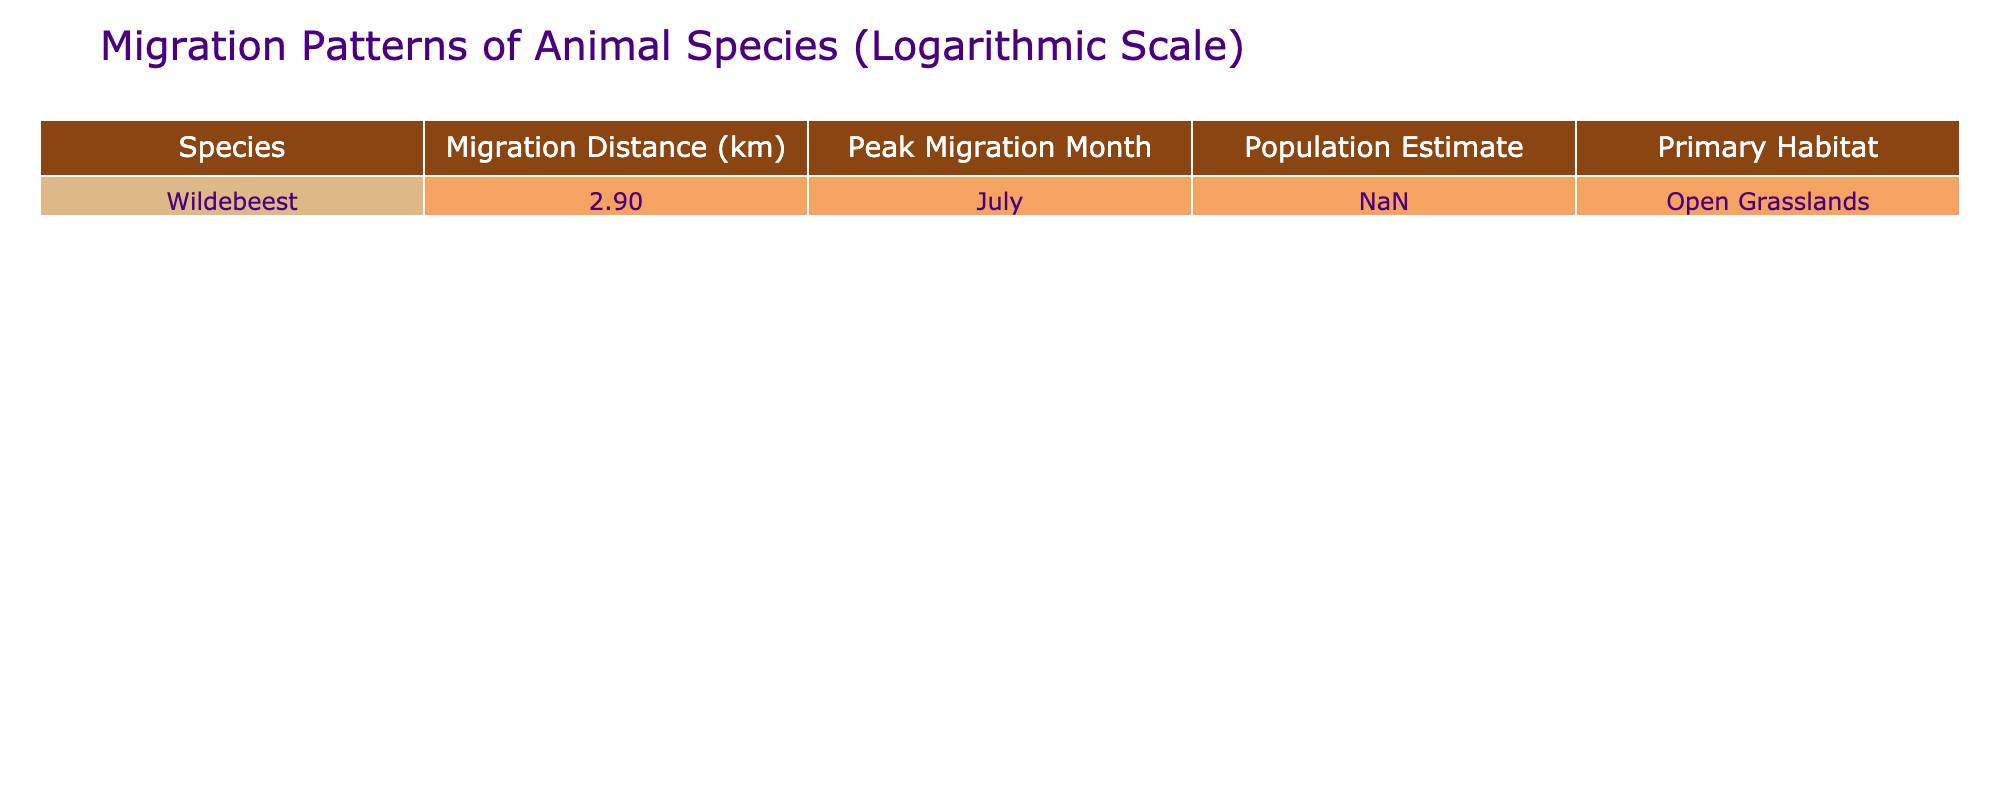What is the migration distance of the wildebeest? The table clearly states that the migration distance for the wildebeest is 800 km.
Answer: 800 km In which month do wildebeests peak their migration? According to the table, the peak migration month for wildebeests is July.
Answer: July What is the population estimate for wildebeests? The table shows that the population estimate for wildebeests is 1.5 million.
Answer: 1.5 million Is the primary habitat of the wildebeest open grasslands? The table specifies that the primary habitat for the wildebeest is indeed open grasslands.
Answer: Yes What is the logarithmic value of the migration distance for the wildebeest? The migration distance is 800 km. When we take the logarithm base 10 of 800, we get approximately 2.903, which is presented in the table.
Answer: 2.90 What is the difference in migration distance between the wildebeest and any other species, if available? Since there is only one species listed in the table, we cannot calculate a difference. Therefore, we do not have any other species for comparison.
Answer: N/A If the peak migration month for the wildebeest is in July, what can be inferred about the seasonality of their migration? Based on the table, the peak in July suggests that the migration is aligned with certain seasonal conditions, likely related to weather and available resources during that month in the Serengeti. This highlights their migration as a seasonal event.
Answer: Seasonal event What is the total estimated population if only the wildebeest is considered? The table states the population of the wildebeest as 1.5 million, which is the total for this species since no others are provided. Thus, the total is simply 1.5 million for wildebeests.
Answer: 1.5 million 